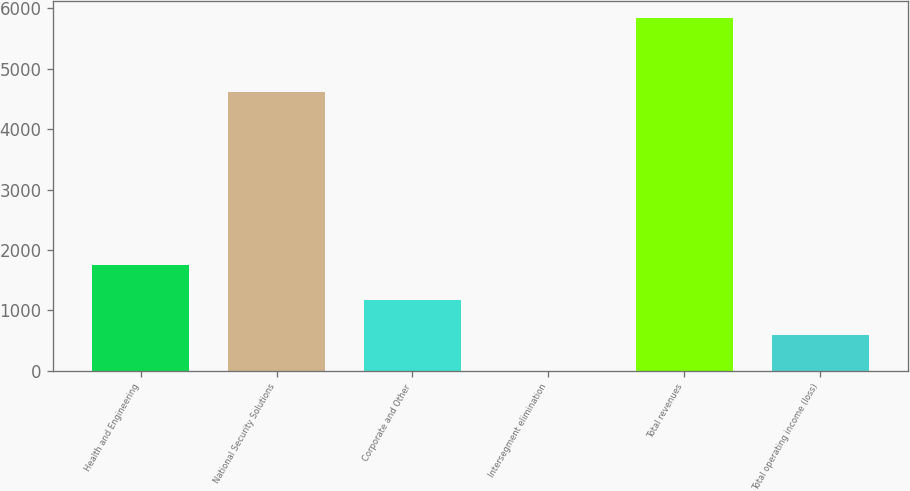Convert chart. <chart><loc_0><loc_0><loc_500><loc_500><bar_chart><fcel>Health and Engineering<fcel>National Security Solutions<fcel>Corporate and Other<fcel>Intersegment elimination<fcel>Total revenues<fcel>Total operating income (loss)<nl><fcel>1753.6<fcel>4618<fcel>1170.4<fcel>4<fcel>5836<fcel>587.2<nl></chart> 